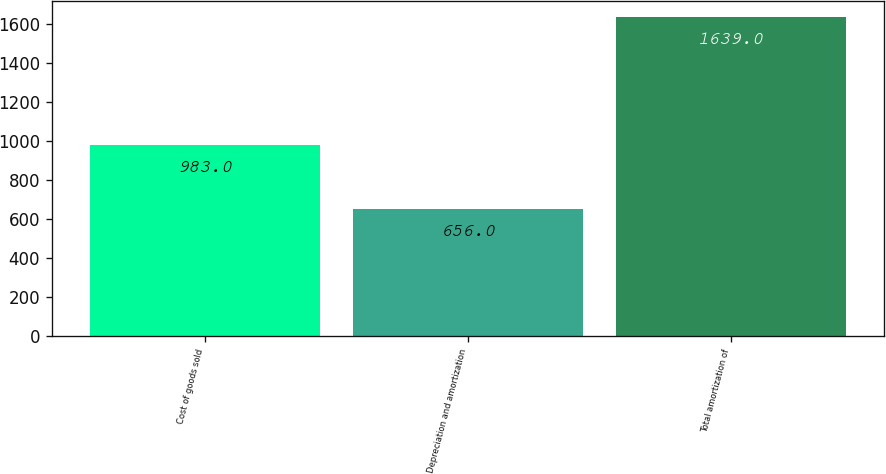<chart> <loc_0><loc_0><loc_500><loc_500><bar_chart><fcel>Cost of goods sold<fcel>Depreciation and amortization<fcel>Total amortization of<nl><fcel>983<fcel>656<fcel>1639<nl></chart> 